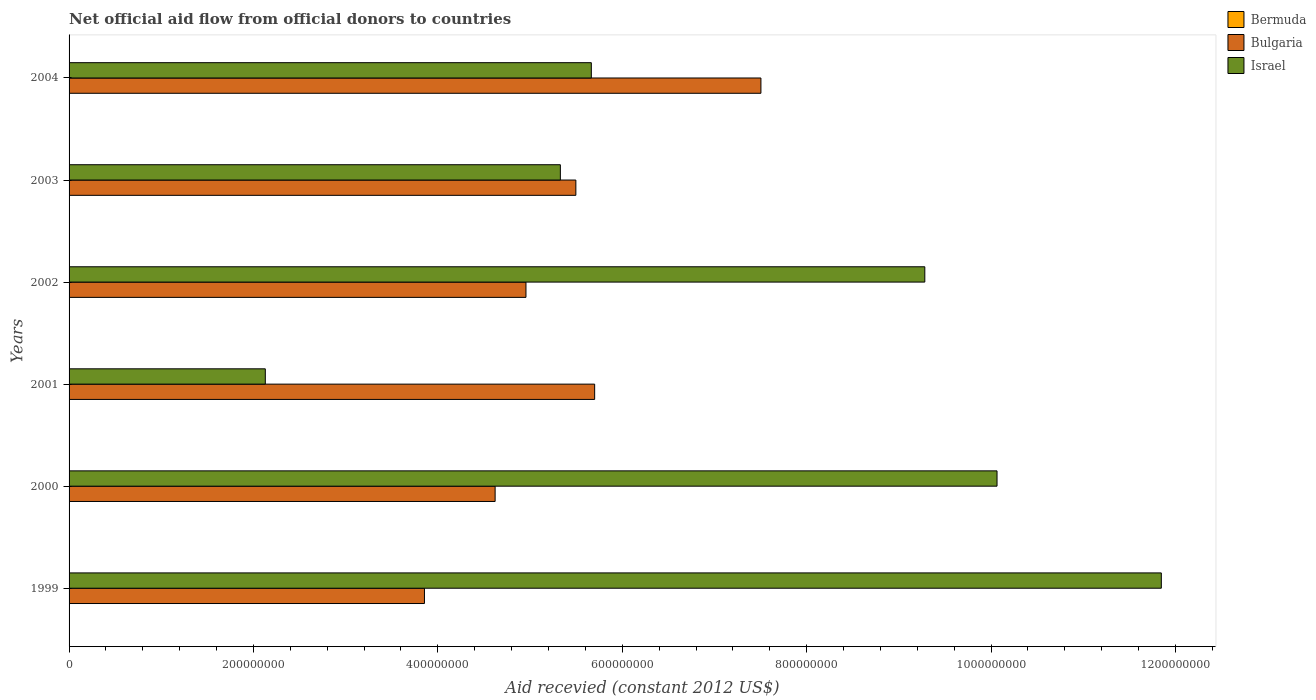How many groups of bars are there?
Provide a short and direct response. 6. Are the number of bars per tick equal to the number of legend labels?
Make the answer very short. Yes. Are the number of bars on each tick of the Y-axis equal?
Provide a short and direct response. Yes. In how many cases, is the number of bars for a given year not equal to the number of legend labels?
Offer a terse response. 0. Across all years, what is the maximum total aid received in Israel?
Make the answer very short. 1.18e+09. Across all years, what is the minimum total aid received in Bulgaria?
Your answer should be very brief. 3.85e+08. In which year was the total aid received in Bulgaria maximum?
Keep it short and to the point. 2004. What is the total total aid received in Israel in the graph?
Ensure brevity in your answer.  4.43e+09. What is the difference between the total aid received in Israel in 1999 and the total aid received in Bermuda in 2002?
Your response must be concise. 1.18e+09. What is the average total aid received in Bermuda per year?
Offer a very short reply. 7.67e+04. In the year 2000, what is the difference between the total aid received in Bermuda and total aid received in Bulgaria?
Ensure brevity in your answer.  -4.62e+08. In how many years, is the total aid received in Bermuda greater than 760000000 US$?
Your answer should be very brief. 0. What is the ratio of the total aid received in Bermuda in 2001 to that in 2002?
Provide a short and direct response. 1.33. Is the total aid received in Bermuda in 2001 less than that in 2003?
Your answer should be compact. No. What is the difference between the highest and the second highest total aid received in Bulgaria?
Your answer should be compact. 1.80e+08. What is the difference between the highest and the lowest total aid received in Bulgaria?
Your response must be concise. 3.65e+08. What does the 2nd bar from the bottom in 2003 represents?
Offer a terse response. Bulgaria. Is it the case that in every year, the sum of the total aid received in Israel and total aid received in Bulgaria is greater than the total aid received in Bermuda?
Offer a terse response. Yes. Are all the bars in the graph horizontal?
Make the answer very short. Yes. What is the difference between two consecutive major ticks on the X-axis?
Give a very brief answer. 2.00e+08. Does the graph contain grids?
Provide a succinct answer. No. How many legend labels are there?
Offer a terse response. 3. How are the legend labels stacked?
Ensure brevity in your answer.  Vertical. What is the title of the graph?
Your response must be concise. Net official aid flow from official donors to countries. What is the label or title of the X-axis?
Your answer should be compact. Aid recevied (constant 2012 US$). What is the Aid recevied (constant 2012 US$) in Bermuda in 1999?
Make the answer very short. 1.30e+05. What is the Aid recevied (constant 2012 US$) of Bulgaria in 1999?
Offer a very short reply. 3.85e+08. What is the Aid recevied (constant 2012 US$) in Israel in 1999?
Keep it short and to the point. 1.18e+09. What is the Aid recevied (constant 2012 US$) of Bulgaria in 2000?
Give a very brief answer. 4.62e+08. What is the Aid recevied (constant 2012 US$) of Israel in 2000?
Provide a succinct answer. 1.01e+09. What is the Aid recevied (constant 2012 US$) of Bermuda in 2001?
Your response must be concise. 4.00e+04. What is the Aid recevied (constant 2012 US$) of Bulgaria in 2001?
Your answer should be compact. 5.70e+08. What is the Aid recevied (constant 2012 US$) in Israel in 2001?
Ensure brevity in your answer.  2.13e+08. What is the Aid recevied (constant 2012 US$) of Bermuda in 2002?
Keep it short and to the point. 3.00e+04. What is the Aid recevied (constant 2012 US$) of Bulgaria in 2002?
Your answer should be very brief. 4.96e+08. What is the Aid recevied (constant 2012 US$) in Israel in 2002?
Keep it short and to the point. 9.28e+08. What is the Aid recevied (constant 2012 US$) in Bulgaria in 2003?
Your response must be concise. 5.50e+08. What is the Aid recevied (constant 2012 US$) of Israel in 2003?
Give a very brief answer. 5.33e+08. What is the Aid recevied (constant 2012 US$) of Bulgaria in 2004?
Your response must be concise. 7.50e+08. What is the Aid recevied (constant 2012 US$) of Israel in 2004?
Your response must be concise. 5.66e+08. Across all years, what is the maximum Aid recevied (constant 2012 US$) of Bermuda?
Your answer should be compact. 1.30e+05. Across all years, what is the maximum Aid recevied (constant 2012 US$) in Bulgaria?
Offer a very short reply. 7.50e+08. Across all years, what is the maximum Aid recevied (constant 2012 US$) in Israel?
Give a very brief answer. 1.18e+09. Across all years, what is the minimum Aid recevied (constant 2012 US$) of Bulgaria?
Provide a short and direct response. 3.85e+08. Across all years, what is the minimum Aid recevied (constant 2012 US$) of Israel?
Offer a very short reply. 2.13e+08. What is the total Aid recevied (constant 2012 US$) of Bulgaria in the graph?
Make the answer very short. 3.21e+09. What is the total Aid recevied (constant 2012 US$) of Israel in the graph?
Offer a very short reply. 4.43e+09. What is the difference between the Aid recevied (constant 2012 US$) of Bermuda in 1999 and that in 2000?
Provide a short and direct response. 2.00e+04. What is the difference between the Aid recevied (constant 2012 US$) in Bulgaria in 1999 and that in 2000?
Provide a short and direct response. -7.66e+07. What is the difference between the Aid recevied (constant 2012 US$) of Israel in 1999 and that in 2000?
Offer a very short reply. 1.78e+08. What is the difference between the Aid recevied (constant 2012 US$) in Bulgaria in 1999 and that in 2001?
Your response must be concise. -1.85e+08. What is the difference between the Aid recevied (constant 2012 US$) in Israel in 1999 and that in 2001?
Give a very brief answer. 9.72e+08. What is the difference between the Aid recevied (constant 2012 US$) of Bulgaria in 1999 and that in 2002?
Offer a very short reply. -1.10e+08. What is the difference between the Aid recevied (constant 2012 US$) of Israel in 1999 and that in 2002?
Offer a terse response. 2.57e+08. What is the difference between the Aid recevied (constant 2012 US$) in Bulgaria in 1999 and that in 2003?
Give a very brief answer. -1.64e+08. What is the difference between the Aid recevied (constant 2012 US$) of Israel in 1999 and that in 2003?
Your answer should be compact. 6.52e+08. What is the difference between the Aid recevied (constant 2012 US$) of Bulgaria in 1999 and that in 2004?
Your answer should be very brief. -3.65e+08. What is the difference between the Aid recevied (constant 2012 US$) of Israel in 1999 and that in 2004?
Offer a terse response. 6.18e+08. What is the difference between the Aid recevied (constant 2012 US$) of Bermuda in 2000 and that in 2001?
Provide a short and direct response. 7.00e+04. What is the difference between the Aid recevied (constant 2012 US$) of Bulgaria in 2000 and that in 2001?
Your answer should be very brief. -1.08e+08. What is the difference between the Aid recevied (constant 2012 US$) of Israel in 2000 and that in 2001?
Keep it short and to the point. 7.94e+08. What is the difference between the Aid recevied (constant 2012 US$) in Bermuda in 2000 and that in 2002?
Ensure brevity in your answer.  8.00e+04. What is the difference between the Aid recevied (constant 2012 US$) in Bulgaria in 2000 and that in 2002?
Give a very brief answer. -3.34e+07. What is the difference between the Aid recevied (constant 2012 US$) of Israel in 2000 and that in 2002?
Ensure brevity in your answer.  7.83e+07. What is the difference between the Aid recevied (constant 2012 US$) of Bulgaria in 2000 and that in 2003?
Keep it short and to the point. -8.76e+07. What is the difference between the Aid recevied (constant 2012 US$) of Israel in 2000 and that in 2003?
Keep it short and to the point. 4.74e+08. What is the difference between the Aid recevied (constant 2012 US$) of Bermuda in 2000 and that in 2004?
Offer a very short reply. 0. What is the difference between the Aid recevied (constant 2012 US$) of Bulgaria in 2000 and that in 2004?
Offer a terse response. -2.88e+08. What is the difference between the Aid recevied (constant 2012 US$) in Israel in 2000 and that in 2004?
Your response must be concise. 4.40e+08. What is the difference between the Aid recevied (constant 2012 US$) of Bulgaria in 2001 and that in 2002?
Provide a short and direct response. 7.45e+07. What is the difference between the Aid recevied (constant 2012 US$) of Israel in 2001 and that in 2002?
Offer a terse response. -7.15e+08. What is the difference between the Aid recevied (constant 2012 US$) of Bulgaria in 2001 and that in 2003?
Give a very brief answer. 2.04e+07. What is the difference between the Aid recevied (constant 2012 US$) in Israel in 2001 and that in 2003?
Your response must be concise. -3.20e+08. What is the difference between the Aid recevied (constant 2012 US$) in Bulgaria in 2001 and that in 2004?
Provide a short and direct response. -1.80e+08. What is the difference between the Aid recevied (constant 2012 US$) of Israel in 2001 and that in 2004?
Make the answer very short. -3.54e+08. What is the difference between the Aid recevied (constant 2012 US$) in Bermuda in 2002 and that in 2003?
Your answer should be very brief. -10000. What is the difference between the Aid recevied (constant 2012 US$) in Bulgaria in 2002 and that in 2003?
Make the answer very short. -5.41e+07. What is the difference between the Aid recevied (constant 2012 US$) of Israel in 2002 and that in 2003?
Ensure brevity in your answer.  3.95e+08. What is the difference between the Aid recevied (constant 2012 US$) of Bulgaria in 2002 and that in 2004?
Provide a short and direct response. -2.55e+08. What is the difference between the Aid recevied (constant 2012 US$) of Israel in 2002 and that in 2004?
Offer a very short reply. 3.62e+08. What is the difference between the Aid recevied (constant 2012 US$) in Bulgaria in 2003 and that in 2004?
Your response must be concise. -2.01e+08. What is the difference between the Aid recevied (constant 2012 US$) of Israel in 2003 and that in 2004?
Provide a succinct answer. -3.36e+07. What is the difference between the Aid recevied (constant 2012 US$) of Bermuda in 1999 and the Aid recevied (constant 2012 US$) of Bulgaria in 2000?
Offer a terse response. -4.62e+08. What is the difference between the Aid recevied (constant 2012 US$) of Bermuda in 1999 and the Aid recevied (constant 2012 US$) of Israel in 2000?
Provide a succinct answer. -1.01e+09. What is the difference between the Aid recevied (constant 2012 US$) in Bulgaria in 1999 and the Aid recevied (constant 2012 US$) in Israel in 2000?
Your answer should be very brief. -6.21e+08. What is the difference between the Aid recevied (constant 2012 US$) of Bermuda in 1999 and the Aid recevied (constant 2012 US$) of Bulgaria in 2001?
Provide a succinct answer. -5.70e+08. What is the difference between the Aid recevied (constant 2012 US$) in Bermuda in 1999 and the Aid recevied (constant 2012 US$) in Israel in 2001?
Make the answer very short. -2.13e+08. What is the difference between the Aid recevied (constant 2012 US$) of Bulgaria in 1999 and the Aid recevied (constant 2012 US$) of Israel in 2001?
Offer a terse response. 1.73e+08. What is the difference between the Aid recevied (constant 2012 US$) in Bermuda in 1999 and the Aid recevied (constant 2012 US$) in Bulgaria in 2002?
Your response must be concise. -4.95e+08. What is the difference between the Aid recevied (constant 2012 US$) in Bermuda in 1999 and the Aid recevied (constant 2012 US$) in Israel in 2002?
Your answer should be very brief. -9.28e+08. What is the difference between the Aid recevied (constant 2012 US$) in Bulgaria in 1999 and the Aid recevied (constant 2012 US$) in Israel in 2002?
Keep it short and to the point. -5.43e+08. What is the difference between the Aid recevied (constant 2012 US$) in Bermuda in 1999 and the Aid recevied (constant 2012 US$) in Bulgaria in 2003?
Your answer should be very brief. -5.50e+08. What is the difference between the Aid recevied (constant 2012 US$) of Bermuda in 1999 and the Aid recevied (constant 2012 US$) of Israel in 2003?
Keep it short and to the point. -5.33e+08. What is the difference between the Aid recevied (constant 2012 US$) in Bulgaria in 1999 and the Aid recevied (constant 2012 US$) in Israel in 2003?
Keep it short and to the point. -1.47e+08. What is the difference between the Aid recevied (constant 2012 US$) in Bermuda in 1999 and the Aid recevied (constant 2012 US$) in Bulgaria in 2004?
Offer a very short reply. -7.50e+08. What is the difference between the Aid recevied (constant 2012 US$) of Bermuda in 1999 and the Aid recevied (constant 2012 US$) of Israel in 2004?
Make the answer very short. -5.66e+08. What is the difference between the Aid recevied (constant 2012 US$) in Bulgaria in 1999 and the Aid recevied (constant 2012 US$) in Israel in 2004?
Keep it short and to the point. -1.81e+08. What is the difference between the Aid recevied (constant 2012 US$) of Bermuda in 2000 and the Aid recevied (constant 2012 US$) of Bulgaria in 2001?
Your response must be concise. -5.70e+08. What is the difference between the Aid recevied (constant 2012 US$) in Bermuda in 2000 and the Aid recevied (constant 2012 US$) in Israel in 2001?
Your answer should be compact. -2.13e+08. What is the difference between the Aid recevied (constant 2012 US$) of Bulgaria in 2000 and the Aid recevied (constant 2012 US$) of Israel in 2001?
Keep it short and to the point. 2.49e+08. What is the difference between the Aid recevied (constant 2012 US$) in Bermuda in 2000 and the Aid recevied (constant 2012 US$) in Bulgaria in 2002?
Your answer should be very brief. -4.95e+08. What is the difference between the Aid recevied (constant 2012 US$) of Bermuda in 2000 and the Aid recevied (constant 2012 US$) of Israel in 2002?
Offer a very short reply. -9.28e+08. What is the difference between the Aid recevied (constant 2012 US$) in Bulgaria in 2000 and the Aid recevied (constant 2012 US$) in Israel in 2002?
Provide a succinct answer. -4.66e+08. What is the difference between the Aid recevied (constant 2012 US$) of Bermuda in 2000 and the Aid recevied (constant 2012 US$) of Bulgaria in 2003?
Provide a succinct answer. -5.50e+08. What is the difference between the Aid recevied (constant 2012 US$) in Bermuda in 2000 and the Aid recevied (constant 2012 US$) in Israel in 2003?
Provide a succinct answer. -5.33e+08. What is the difference between the Aid recevied (constant 2012 US$) of Bulgaria in 2000 and the Aid recevied (constant 2012 US$) of Israel in 2003?
Keep it short and to the point. -7.08e+07. What is the difference between the Aid recevied (constant 2012 US$) of Bermuda in 2000 and the Aid recevied (constant 2012 US$) of Bulgaria in 2004?
Offer a very short reply. -7.50e+08. What is the difference between the Aid recevied (constant 2012 US$) in Bermuda in 2000 and the Aid recevied (constant 2012 US$) in Israel in 2004?
Your answer should be very brief. -5.66e+08. What is the difference between the Aid recevied (constant 2012 US$) of Bulgaria in 2000 and the Aid recevied (constant 2012 US$) of Israel in 2004?
Keep it short and to the point. -1.04e+08. What is the difference between the Aid recevied (constant 2012 US$) of Bermuda in 2001 and the Aid recevied (constant 2012 US$) of Bulgaria in 2002?
Provide a short and direct response. -4.96e+08. What is the difference between the Aid recevied (constant 2012 US$) of Bermuda in 2001 and the Aid recevied (constant 2012 US$) of Israel in 2002?
Your answer should be very brief. -9.28e+08. What is the difference between the Aid recevied (constant 2012 US$) of Bulgaria in 2001 and the Aid recevied (constant 2012 US$) of Israel in 2002?
Ensure brevity in your answer.  -3.58e+08. What is the difference between the Aid recevied (constant 2012 US$) in Bermuda in 2001 and the Aid recevied (constant 2012 US$) in Bulgaria in 2003?
Your answer should be compact. -5.50e+08. What is the difference between the Aid recevied (constant 2012 US$) of Bermuda in 2001 and the Aid recevied (constant 2012 US$) of Israel in 2003?
Offer a very short reply. -5.33e+08. What is the difference between the Aid recevied (constant 2012 US$) in Bulgaria in 2001 and the Aid recevied (constant 2012 US$) in Israel in 2003?
Your answer should be compact. 3.72e+07. What is the difference between the Aid recevied (constant 2012 US$) in Bermuda in 2001 and the Aid recevied (constant 2012 US$) in Bulgaria in 2004?
Provide a succinct answer. -7.50e+08. What is the difference between the Aid recevied (constant 2012 US$) in Bermuda in 2001 and the Aid recevied (constant 2012 US$) in Israel in 2004?
Provide a succinct answer. -5.66e+08. What is the difference between the Aid recevied (constant 2012 US$) of Bulgaria in 2001 and the Aid recevied (constant 2012 US$) of Israel in 2004?
Keep it short and to the point. 3.60e+06. What is the difference between the Aid recevied (constant 2012 US$) in Bermuda in 2002 and the Aid recevied (constant 2012 US$) in Bulgaria in 2003?
Provide a short and direct response. -5.50e+08. What is the difference between the Aid recevied (constant 2012 US$) in Bermuda in 2002 and the Aid recevied (constant 2012 US$) in Israel in 2003?
Your answer should be very brief. -5.33e+08. What is the difference between the Aid recevied (constant 2012 US$) of Bulgaria in 2002 and the Aid recevied (constant 2012 US$) of Israel in 2003?
Offer a terse response. -3.73e+07. What is the difference between the Aid recevied (constant 2012 US$) of Bermuda in 2002 and the Aid recevied (constant 2012 US$) of Bulgaria in 2004?
Your response must be concise. -7.50e+08. What is the difference between the Aid recevied (constant 2012 US$) in Bermuda in 2002 and the Aid recevied (constant 2012 US$) in Israel in 2004?
Provide a short and direct response. -5.66e+08. What is the difference between the Aid recevied (constant 2012 US$) of Bulgaria in 2002 and the Aid recevied (constant 2012 US$) of Israel in 2004?
Offer a terse response. -7.09e+07. What is the difference between the Aid recevied (constant 2012 US$) of Bermuda in 2003 and the Aid recevied (constant 2012 US$) of Bulgaria in 2004?
Your response must be concise. -7.50e+08. What is the difference between the Aid recevied (constant 2012 US$) of Bermuda in 2003 and the Aid recevied (constant 2012 US$) of Israel in 2004?
Your answer should be compact. -5.66e+08. What is the difference between the Aid recevied (constant 2012 US$) of Bulgaria in 2003 and the Aid recevied (constant 2012 US$) of Israel in 2004?
Ensure brevity in your answer.  -1.68e+07. What is the average Aid recevied (constant 2012 US$) in Bermuda per year?
Give a very brief answer. 7.67e+04. What is the average Aid recevied (constant 2012 US$) in Bulgaria per year?
Your answer should be very brief. 5.36e+08. What is the average Aid recevied (constant 2012 US$) of Israel per year?
Offer a very short reply. 7.39e+08. In the year 1999, what is the difference between the Aid recevied (constant 2012 US$) of Bermuda and Aid recevied (constant 2012 US$) of Bulgaria?
Offer a very short reply. -3.85e+08. In the year 1999, what is the difference between the Aid recevied (constant 2012 US$) in Bermuda and Aid recevied (constant 2012 US$) in Israel?
Your answer should be compact. -1.18e+09. In the year 1999, what is the difference between the Aid recevied (constant 2012 US$) of Bulgaria and Aid recevied (constant 2012 US$) of Israel?
Provide a succinct answer. -7.99e+08. In the year 2000, what is the difference between the Aid recevied (constant 2012 US$) in Bermuda and Aid recevied (constant 2012 US$) in Bulgaria?
Provide a short and direct response. -4.62e+08. In the year 2000, what is the difference between the Aid recevied (constant 2012 US$) in Bermuda and Aid recevied (constant 2012 US$) in Israel?
Ensure brevity in your answer.  -1.01e+09. In the year 2000, what is the difference between the Aid recevied (constant 2012 US$) in Bulgaria and Aid recevied (constant 2012 US$) in Israel?
Provide a succinct answer. -5.44e+08. In the year 2001, what is the difference between the Aid recevied (constant 2012 US$) of Bermuda and Aid recevied (constant 2012 US$) of Bulgaria?
Offer a very short reply. -5.70e+08. In the year 2001, what is the difference between the Aid recevied (constant 2012 US$) in Bermuda and Aid recevied (constant 2012 US$) in Israel?
Offer a terse response. -2.13e+08. In the year 2001, what is the difference between the Aid recevied (constant 2012 US$) of Bulgaria and Aid recevied (constant 2012 US$) of Israel?
Give a very brief answer. 3.57e+08. In the year 2002, what is the difference between the Aid recevied (constant 2012 US$) of Bermuda and Aid recevied (constant 2012 US$) of Bulgaria?
Your response must be concise. -4.96e+08. In the year 2002, what is the difference between the Aid recevied (constant 2012 US$) of Bermuda and Aid recevied (constant 2012 US$) of Israel?
Provide a short and direct response. -9.28e+08. In the year 2002, what is the difference between the Aid recevied (constant 2012 US$) in Bulgaria and Aid recevied (constant 2012 US$) in Israel?
Keep it short and to the point. -4.33e+08. In the year 2003, what is the difference between the Aid recevied (constant 2012 US$) of Bermuda and Aid recevied (constant 2012 US$) of Bulgaria?
Offer a terse response. -5.50e+08. In the year 2003, what is the difference between the Aid recevied (constant 2012 US$) in Bermuda and Aid recevied (constant 2012 US$) in Israel?
Ensure brevity in your answer.  -5.33e+08. In the year 2003, what is the difference between the Aid recevied (constant 2012 US$) in Bulgaria and Aid recevied (constant 2012 US$) in Israel?
Offer a terse response. 1.68e+07. In the year 2004, what is the difference between the Aid recevied (constant 2012 US$) in Bermuda and Aid recevied (constant 2012 US$) in Bulgaria?
Your response must be concise. -7.50e+08. In the year 2004, what is the difference between the Aid recevied (constant 2012 US$) of Bermuda and Aid recevied (constant 2012 US$) of Israel?
Your answer should be compact. -5.66e+08. In the year 2004, what is the difference between the Aid recevied (constant 2012 US$) of Bulgaria and Aid recevied (constant 2012 US$) of Israel?
Ensure brevity in your answer.  1.84e+08. What is the ratio of the Aid recevied (constant 2012 US$) in Bermuda in 1999 to that in 2000?
Your answer should be compact. 1.18. What is the ratio of the Aid recevied (constant 2012 US$) of Bulgaria in 1999 to that in 2000?
Ensure brevity in your answer.  0.83. What is the ratio of the Aid recevied (constant 2012 US$) in Israel in 1999 to that in 2000?
Your answer should be very brief. 1.18. What is the ratio of the Aid recevied (constant 2012 US$) of Bermuda in 1999 to that in 2001?
Make the answer very short. 3.25. What is the ratio of the Aid recevied (constant 2012 US$) in Bulgaria in 1999 to that in 2001?
Provide a succinct answer. 0.68. What is the ratio of the Aid recevied (constant 2012 US$) in Israel in 1999 to that in 2001?
Offer a terse response. 5.57. What is the ratio of the Aid recevied (constant 2012 US$) in Bermuda in 1999 to that in 2002?
Your answer should be compact. 4.33. What is the ratio of the Aid recevied (constant 2012 US$) of Bulgaria in 1999 to that in 2002?
Provide a succinct answer. 0.78. What is the ratio of the Aid recevied (constant 2012 US$) in Israel in 1999 to that in 2002?
Make the answer very short. 1.28. What is the ratio of the Aid recevied (constant 2012 US$) of Bermuda in 1999 to that in 2003?
Give a very brief answer. 3.25. What is the ratio of the Aid recevied (constant 2012 US$) in Bulgaria in 1999 to that in 2003?
Keep it short and to the point. 0.7. What is the ratio of the Aid recevied (constant 2012 US$) of Israel in 1999 to that in 2003?
Your answer should be very brief. 2.22. What is the ratio of the Aid recevied (constant 2012 US$) of Bermuda in 1999 to that in 2004?
Keep it short and to the point. 1.18. What is the ratio of the Aid recevied (constant 2012 US$) in Bulgaria in 1999 to that in 2004?
Your response must be concise. 0.51. What is the ratio of the Aid recevied (constant 2012 US$) in Israel in 1999 to that in 2004?
Your answer should be very brief. 2.09. What is the ratio of the Aid recevied (constant 2012 US$) in Bermuda in 2000 to that in 2001?
Your answer should be compact. 2.75. What is the ratio of the Aid recevied (constant 2012 US$) of Bulgaria in 2000 to that in 2001?
Provide a succinct answer. 0.81. What is the ratio of the Aid recevied (constant 2012 US$) in Israel in 2000 to that in 2001?
Your answer should be very brief. 4.73. What is the ratio of the Aid recevied (constant 2012 US$) of Bermuda in 2000 to that in 2002?
Ensure brevity in your answer.  3.67. What is the ratio of the Aid recevied (constant 2012 US$) in Bulgaria in 2000 to that in 2002?
Offer a very short reply. 0.93. What is the ratio of the Aid recevied (constant 2012 US$) of Israel in 2000 to that in 2002?
Keep it short and to the point. 1.08. What is the ratio of the Aid recevied (constant 2012 US$) in Bermuda in 2000 to that in 2003?
Ensure brevity in your answer.  2.75. What is the ratio of the Aid recevied (constant 2012 US$) in Bulgaria in 2000 to that in 2003?
Provide a succinct answer. 0.84. What is the ratio of the Aid recevied (constant 2012 US$) in Israel in 2000 to that in 2003?
Your answer should be very brief. 1.89. What is the ratio of the Aid recevied (constant 2012 US$) in Bulgaria in 2000 to that in 2004?
Provide a short and direct response. 0.62. What is the ratio of the Aid recevied (constant 2012 US$) in Israel in 2000 to that in 2004?
Provide a succinct answer. 1.78. What is the ratio of the Aid recevied (constant 2012 US$) in Bermuda in 2001 to that in 2002?
Give a very brief answer. 1.33. What is the ratio of the Aid recevied (constant 2012 US$) of Bulgaria in 2001 to that in 2002?
Keep it short and to the point. 1.15. What is the ratio of the Aid recevied (constant 2012 US$) in Israel in 2001 to that in 2002?
Provide a short and direct response. 0.23. What is the ratio of the Aid recevied (constant 2012 US$) in Bermuda in 2001 to that in 2003?
Ensure brevity in your answer.  1. What is the ratio of the Aid recevied (constant 2012 US$) in Bulgaria in 2001 to that in 2003?
Provide a succinct answer. 1.04. What is the ratio of the Aid recevied (constant 2012 US$) of Israel in 2001 to that in 2003?
Provide a succinct answer. 0.4. What is the ratio of the Aid recevied (constant 2012 US$) of Bermuda in 2001 to that in 2004?
Your answer should be compact. 0.36. What is the ratio of the Aid recevied (constant 2012 US$) of Bulgaria in 2001 to that in 2004?
Your answer should be very brief. 0.76. What is the ratio of the Aid recevied (constant 2012 US$) of Israel in 2001 to that in 2004?
Make the answer very short. 0.38. What is the ratio of the Aid recevied (constant 2012 US$) in Bulgaria in 2002 to that in 2003?
Keep it short and to the point. 0.9. What is the ratio of the Aid recevied (constant 2012 US$) of Israel in 2002 to that in 2003?
Make the answer very short. 1.74. What is the ratio of the Aid recevied (constant 2012 US$) in Bermuda in 2002 to that in 2004?
Keep it short and to the point. 0.27. What is the ratio of the Aid recevied (constant 2012 US$) of Bulgaria in 2002 to that in 2004?
Make the answer very short. 0.66. What is the ratio of the Aid recevied (constant 2012 US$) of Israel in 2002 to that in 2004?
Provide a succinct answer. 1.64. What is the ratio of the Aid recevied (constant 2012 US$) in Bermuda in 2003 to that in 2004?
Offer a very short reply. 0.36. What is the ratio of the Aid recevied (constant 2012 US$) of Bulgaria in 2003 to that in 2004?
Offer a very short reply. 0.73. What is the ratio of the Aid recevied (constant 2012 US$) of Israel in 2003 to that in 2004?
Provide a succinct answer. 0.94. What is the difference between the highest and the second highest Aid recevied (constant 2012 US$) of Bulgaria?
Your answer should be compact. 1.80e+08. What is the difference between the highest and the second highest Aid recevied (constant 2012 US$) of Israel?
Your response must be concise. 1.78e+08. What is the difference between the highest and the lowest Aid recevied (constant 2012 US$) in Bermuda?
Provide a short and direct response. 1.00e+05. What is the difference between the highest and the lowest Aid recevied (constant 2012 US$) of Bulgaria?
Provide a succinct answer. 3.65e+08. What is the difference between the highest and the lowest Aid recevied (constant 2012 US$) in Israel?
Ensure brevity in your answer.  9.72e+08. 